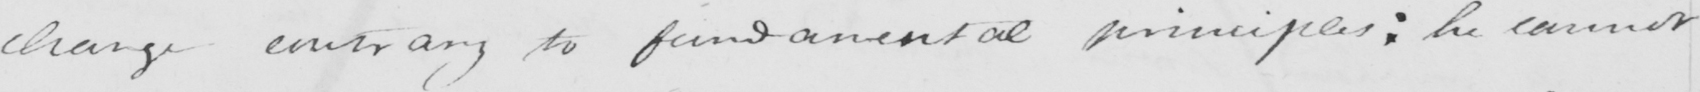Transcribe the text shown in this historical manuscript line. change contrary to fundamental principles :  he cannot 